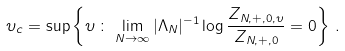<formula> <loc_0><loc_0><loc_500><loc_500>\upsilon _ { c } = \sup \left \{ \upsilon \, \colon \, \lim _ { N \to \infty } | \Lambda _ { N } | ^ { - 1 } \log \frac { Z _ { N , + , 0 , \upsilon } } { Z _ { N , + , 0 } } = 0 \right \} \, .</formula> 